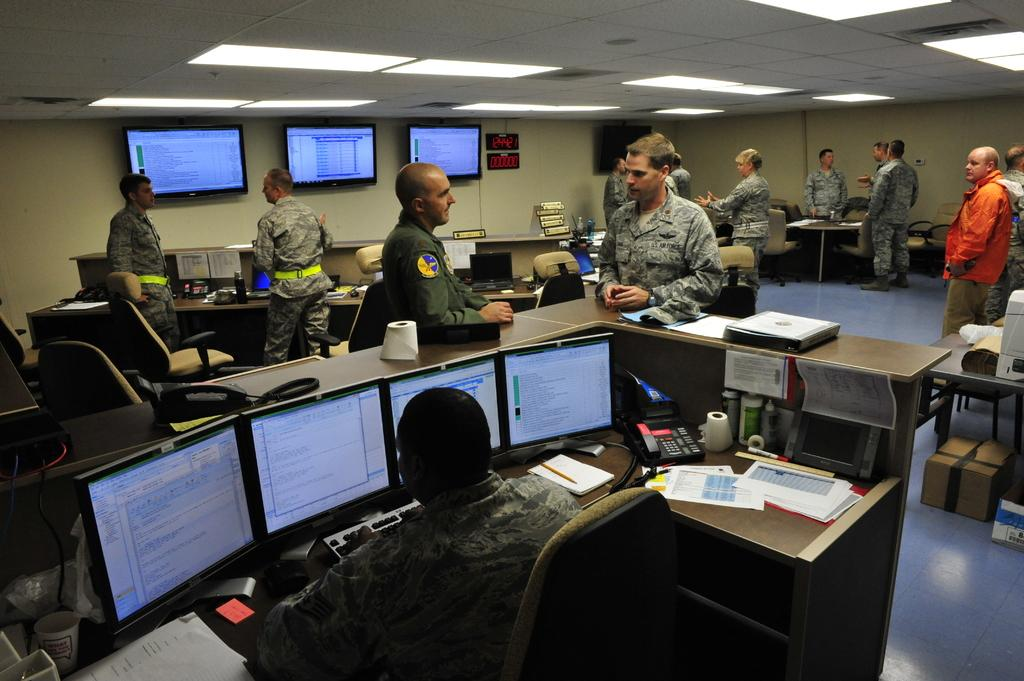What is the police officer doing in the image? The police officer is sitting in a chair. What can be seen in front of the police officer? There are four systems in front of the police officer. Are there any other officers present in the image? Yes, there are other officers standing in front of the police officer. What type of bikes are being used for the activity in the image? There is no activity involving bikes in the image. What type of treatment is being administered to the police officer in the image? There is no treatment being administered to the police officer in the image. 